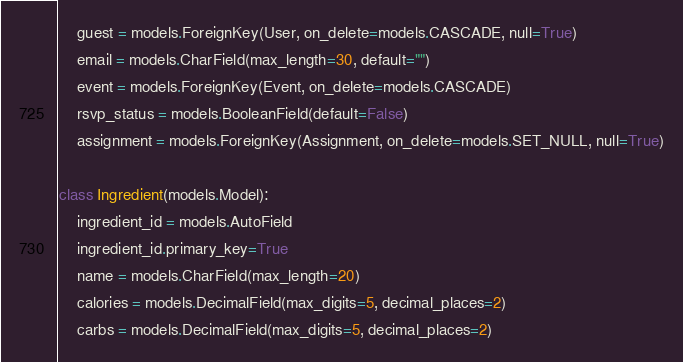<code> <loc_0><loc_0><loc_500><loc_500><_Python_>    guest = models.ForeignKey(User, on_delete=models.CASCADE, null=True)
    email = models.CharField(max_length=30, default="")
    event = models.ForeignKey(Event, on_delete=models.CASCADE)
    rsvp_status = models.BooleanField(default=False)
    assignment = models.ForeignKey(Assignment, on_delete=models.SET_NULL, null=True)
       
class Ingredient(models.Model):
    ingredient_id = models.AutoField
    ingredient_id.primary_key=True
    name = models.CharField(max_length=20)
    calories = models.DecimalField(max_digits=5, decimal_places=2)
    carbs = models.DecimalField(max_digits=5, decimal_places=2)</code> 